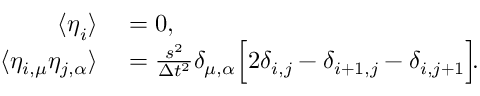Convert formula to latex. <formula><loc_0><loc_0><loc_500><loc_500>\begin{array} { r l } { \langle \eta _ { i } \rangle } & = 0 , } \\ { \langle \eta _ { i , \mu } \eta _ { j , \alpha } \rangle } & = \frac { s ^ { 2 } } { \Delta t ^ { 2 } } \delta _ { \mu , \alpha } \left [ 2 \delta _ { i , j } - \delta _ { i + 1 , j } - \delta _ { i , j + 1 } \right ] \, . } \end{array}</formula> 